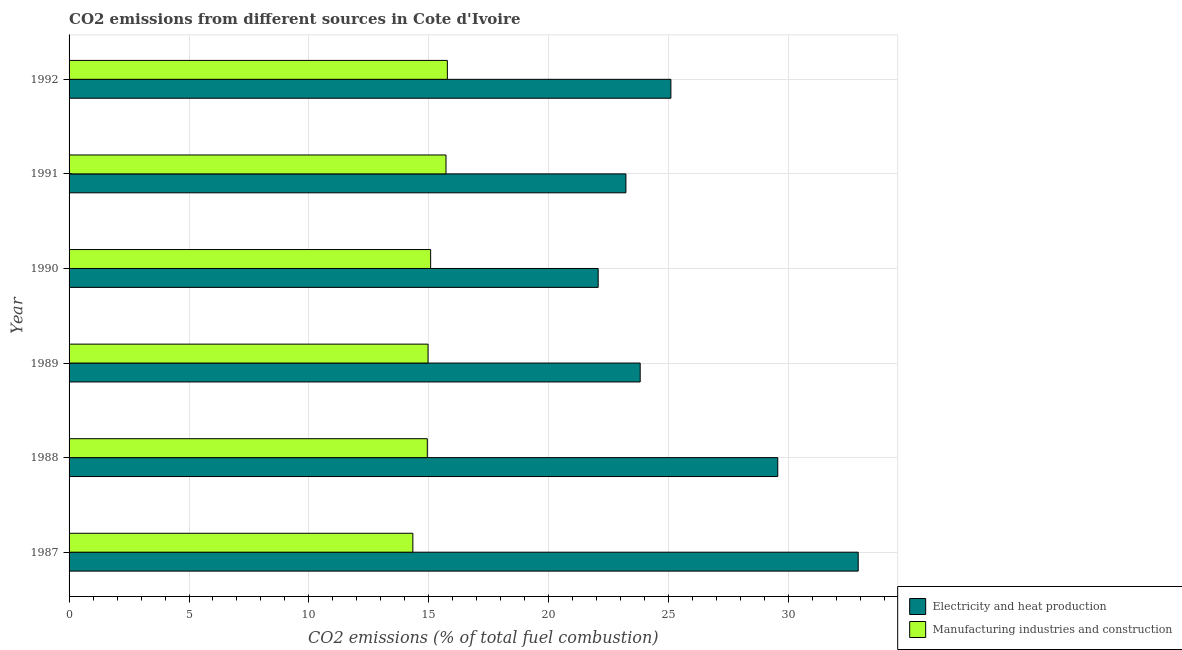How many different coloured bars are there?
Offer a very short reply. 2. How many groups of bars are there?
Offer a very short reply. 6. Are the number of bars per tick equal to the number of legend labels?
Provide a short and direct response. Yes. Are the number of bars on each tick of the Y-axis equal?
Offer a very short reply. Yes. How many bars are there on the 4th tick from the top?
Provide a succinct answer. 2. In how many cases, is the number of bars for a given year not equal to the number of legend labels?
Keep it short and to the point. 0. What is the co2 emissions due to manufacturing industries in 1987?
Your answer should be very brief. 14.33. Across all years, what is the maximum co2 emissions due to electricity and heat production?
Keep it short and to the point. 32.9. Across all years, what is the minimum co2 emissions due to manufacturing industries?
Keep it short and to the point. 14.33. In which year was the co2 emissions due to manufacturing industries maximum?
Provide a succinct answer. 1992. In which year was the co2 emissions due to electricity and heat production minimum?
Offer a terse response. 1990. What is the total co2 emissions due to electricity and heat production in the graph?
Provide a succinct answer. 156.62. What is the difference between the co2 emissions due to electricity and heat production in 1989 and that in 1990?
Keep it short and to the point. 1.75. What is the difference between the co2 emissions due to electricity and heat production in 1990 and the co2 emissions due to manufacturing industries in 1992?
Offer a very short reply. 6.29. What is the average co2 emissions due to manufacturing industries per year?
Ensure brevity in your answer.  15.13. In how many years, is the co2 emissions due to electricity and heat production greater than 24 %?
Keep it short and to the point. 3. What is the ratio of the co2 emissions due to manufacturing industries in 1987 to that in 1992?
Your answer should be very brief. 0.91. Is the difference between the co2 emissions due to manufacturing industries in 1988 and 1992 greater than the difference between the co2 emissions due to electricity and heat production in 1988 and 1992?
Make the answer very short. No. What is the difference between the highest and the second highest co2 emissions due to electricity and heat production?
Offer a terse response. 3.35. What is the difference between the highest and the lowest co2 emissions due to electricity and heat production?
Your answer should be very brief. 10.84. In how many years, is the co2 emissions due to manufacturing industries greater than the average co2 emissions due to manufacturing industries taken over all years?
Your answer should be compact. 2. What does the 1st bar from the top in 1988 represents?
Your response must be concise. Manufacturing industries and construction. What does the 2nd bar from the bottom in 1992 represents?
Offer a very short reply. Manufacturing industries and construction. How many bars are there?
Ensure brevity in your answer.  12. Does the graph contain any zero values?
Give a very brief answer. No. Where does the legend appear in the graph?
Your answer should be compact. Bottom right. How are the legend labels stacked?
Offer a terse response. Vertical. What is the title of the graph?
Your response must be concise. CO2 emissions from different sources in Cote d'Ivoire. Does "Stunting" appear as one of the legend labels in the graph?
Offer a very short reply. No. What is the label or title of the X-axis?
Offer a very short reply. CO2 emissions (% of total fuel combustion). What is the label or title of the Y-axis?
Your answer should be compact. Year. What is the CO2 emissions (% of total fuel combustion) in Electricity and heat production in 1987?
Make the answer very short. 32.9. What is the CO2 emissions (% of total fuel combustion) of Manufacturing industries and construction in 1987?
Ensure brevity in your answer.  14.33. What is the CO2 emissions (% of total fuel combustion) of Electricity and heat production in 1988?
Give a very brief answer. 29.55. What is the CO2 emissions (% of total fuel combustion) in Manufacturing industries and construction in 1988?
Provide a succinct answer. 14.94. What is the CO2 emissions (% of total fuel combustion) in Electricity and heat production in 1989?
Ensure brevity in your answer.  23.81. What is the CO2 emissions (% of total fuel combustion) of Manufacturing industries and construction in 1989?
Keep it short and to the point. 14.97. What is the CO2 emissions (% of total fuel combustion) in Electricity and heat production in 1990?
Your answer should be compact. 22.06. What is the CO2 emissions (% of total fuel combustion) of Manufacturing industries and construction in 1990?
Your response must be concise. 15.07. What is the CO2 emissions (% of total fuel combustion) in Electricity and heat production in 1991?
Keep it short and to the point. 23.21. What is the CO2 emissions (% of total fuel combustion) of Manufacturing industries and construction in 1991?
Your answer should be very brief. 15.71. What is the CO2 emissions (% of total fuel combustion) of Electricity and heat production in 1992?
Your answer should be very brief. 25.09. What is the CO2 emissions (% of total fuel combustion) of Manufacturing industries and construction in 1992?
Offer a very short reply. 15.77. Across all years, what is the maximum CO2 emissions (% of total fuel combustion) of Electricity and heat production?
Offer a very short reply. 32.9. Across all years, what is the maximum CO2 emissions (% of total fuel combustion) in Manufacturing industries and construction?
Offer a terse response. 15.77. Across all years, what is the minimum CO2 emissions (% of total fuel combustion) in Electricity and heat production?
Your answer should be very brief. 22.06. Across all years, what is the minimum CO2 emissions (% of total fuel combustion) in Manufacturing industries and construction?
Provide a short and direct response. 14.33. What is the total CO2 emissions (% of total fuel combustion) of Electricity and heat production in the graph?
Provide a succinct answer. 156.62. What is the total CO2 emissions (% of total fuel combustion) of Manufacturing industries and construction in the graph?
Ensure brevity in your answer.  90.79. What is the difference between the CO2 emissions (% of total fuel combustion) of Electricity and heat production in 1987 and that in 1988?
Your response must be concise. 3.35. What is the difference between the CO2 emissions (% of total fuel combustion) of Manufacturing industries and construction in 1987 and that in 1988?
Ensure brevity in your answer.  -0.6. What is the difference between the CO2 emissions (% of total fuel combustion) in Electricity and heat production in 1987 and that in 1989?
Your answer should be compact. 9.09. What is the difference between the CO2 emissions (% of total fuel combustion) in Manufacturing industries and construction in 1987 and that in 1989?
Provide a succinct answer. -0.63. What is the difference between the CO2 emissions (% of total fuel combustion) in Electricity and heat production in 1987 and that in 1990?
Ensure brevity in your answer.  10.84. What is the difference between the CO2 emissions (% of total fuel combustion) in Manufacturing industries and construction in 1987 and that in 1990?
Offer a very short reply. -0.74. What is the difference between the CO2 emissions (% of total fuel combustion) of Electricity and heat production in 1987 and that in 1991?
Your answer should be compact. 9.68. What is the difference between the CO2 emissions (% of total fuel combustion) of Manufacturing industries and construction in 1987 and that in 1991?
Your answer should be compact. -1.38. What is the difference between the CO2 emissions (% of total fuel combustion) in Electricity and heat production in 1987 and that in 1992?
Provide a succinct answer. 7.81. What is the difference between the CO2 emissions (% of total fuel combustion) in Manufacturing industries and construction in 1987 and that in 1992?
Provide a succinct answer. -1.44. What is the difference between the CO2 emissions (% of total fuel combustion) of Electricity and heat production in 1988 and that in 1989?
Your answer should be very brief. 5.74. What is the difference between the CO2 emissions (% of total fuel combustion) in Manufacturing industries and construction in 1988 and that in 1989?
Keep it short and to the point. -0.03. What is the difference between the CO2 emissions (% of total fuel combustion) in Electricity and heat production in 1988 and that in 1990?
Keep it short and to the point. 7.49. What is the difference between the CO2 emissions (% of total fuel combustion) of Manufacturing industries and construction in 1988 and that in 1990?
Provide a short and direct response. -0.14. What is the difference between the CO2 emissions (% of total fuel combustion) of Electricity and heat production in 1988 and that in 1991?
Make the answer very short. 6.33. What is the difference between the CO2 emissions (% of total fuel combustion) in Manufacturing industries and construction in 1988 and that in 1991?
Offer a very short reply. -0.78. What is the difference between the CO2 emissions (% of total fuel combustion) in Electricity and heat production in 1988 and that in 1992?
Ensure brevity in your answer.  4.46. What is the difference between the CO2 emissions (% of total fuel combustion) of Manufacturing industries and construction in 1988 and that in 1992?
Give a very brief answer. -0.84. What is the difference between the CO2 emissions (% of total fuel combustion) of Electricity and heat production in 1989 and that in 1990?
Keep it short and to the point. 1.75. What is the difference between the CO2 emissions (% of total fuel combustion) of Manufacturing industries and construction in 1989 and that in 1990?
Offer a terse response. -0.11. What is the difference between the CO2 emissions (% of total fuel combustion) of Electricity and heat production in 1989 and that in 1991?
Your response must be concise. 0.6. What is the difference between the CO2 emissions (% of total fuel combustion) of Manufacturing industries and construction in 1989 and that in 1991?
Offer a terse response. -0.75. What is the difference between the CO2 emissions (% of total fuel combustion) of Electricity and heat production in 1989 and that in 1992?
Offer a terse response. -1.28. What is the difference between the CO2 emissions (% of total fuel combustion) in Manufacturing industries and construction in 1989 and that in 1992?
Your response must be concise. -0.8. What is the difference between the CO2 emissions (% of total fuel combustion) of Electricity and heat production in 1990 and that in 1991?
Offer a very short reply. -1.16. What is the difference between the CO2 emissions (% of total fuel combustion) in Manufacturing industries and construction in 1990 and that in 1991?
Your answer should be very brief. -0.64. What is the difference between the CO2 emissions (% of total fuel combustion) of Electricity and heat production in 1990 and that in 1992?
Offer a very short reply. -3.03. What is the difference between the CO2 emissions (% of total fuel combustion) in Manufacturing industries and construction in 1990 and that in 1992?
Make the answer very short. -0.7. What is the difference between the CO2 emissions (% of total fuel combustion) of Electricity and heat production in 1991 and that in 1992?
Offer a very short reply. -1.88. What is the difference between the CO2 emissions (% of total fuel combustion) of Manufacturing industries and construction in 1991 and that in 1992?
Provide a succinct answer. -0.06. What is the difference between the CO2 emissions (% of total fuel combustion) of Electricity and heat production in 1987 and the CO2 emissions (% of total fuel combustion) of Manufacturing industries and construction in 1988?
Ensure brevity in your answer.  17.96. What is the difference between the CO2 emissions (% of total fuel combustion) of Electricity and heat production in 1987 and the CO2 emissions (% of total fuel combustion) of Manufacturing industries and construction in 1989?
Offer a very short reply. 17.93. What is the difference between the CO2 emissions (% of total fuel combustion) of Electricity and heat production in 1987 and the CO2 emissions (% of total fuel combustion) of Manufacturing industries and construction in 1990?
Offer a very short reply. 17.83. What is the difference between the CO2 emissions (% of total fuel combustion) in Electricity and heat production in 1987 and the CO2 emissions (% of total fuel combustion) in Manufacturing industries and construction in 1991?
Your response must be concise. 17.18. What is the difference between the CO2 emissions (% of total fuel combustion) in Electricity and heat production in 1987 and the CO2 emissions (% of total fuel combustion) in Manufacturing industries and construction in 1992?
Provide a short and direct response. 17.13. What is the difference between the CO2 emissions (% of total fuel combustion) of Electricity and heat production in 1988 and the CO2 emissions (% of total fuel combustion) of Manufacturing industries and construction in 1989?
Make the answer very short. 14.58. What is the difference between the CO2 emissions (% of total fuel combustion) in Electricity and heat production in 1988 and the CO2 emissions (% of total fuel combustion) in Manufacturing industries and construction in 1990?
Provide a short and direct response. 14.47. What is the difference between the CO2 emissions (% of total fuel combustion) in Electricity and heat production in 1988 and the CO2 emissions (% of total fuel combustion) in Manufacturing industries and construction in 1991?
Provide a short and direct response. 13.83. What is the difference between the CO2 emissions (% of total fuel combustion) in Electricity and heat production in 1988 and the CO2 emissions (% of total fuel combustion) in Manufacturing industries and construction in 1992?
Give a very brief answer. 13.77. What is the difference between the CO2 emissions (% of total fuel combustion) in Electricity and heat production in 1989 and the CO2 emissions (% of total fuel combustion) in Manufacturing industries and construction in 1990?
Offer a terse response. 8.74. What is the difference between the CO2 emissions (% of total fuel combustion) in Electricity and heat production in 1989 and the CO2 emissions (% of total fuel combustion) in Manufacturing industries and construction in 1991?
Offer a terse response. 8.1. What is the difference between the CO2 emissions (% of total fuel combustion) in Electricity and heat production in 1989 and the CO2 emissions (% of total fuel combustion) in Manufacturing industries and construction in 1992?
Your response must be concise. 8.04. What is the difference between the CO2 emissions (% of total fuel combustion) in Electricity and heat production in 1990 and the CO2 emissions (% of total fuel combustion) in Manufacturing industries and construction in 1991?
Offer a terse response. 6.34. What is the difference between the CO2 emissions (% of total fuel combustion) in Electricity and heat production in 1990 and the CO2 emissions (% of total fuel combustion) in Manufacturing industries and construction in 1992?
Offer a terse response. 6.29. What is the difference between the CO2 emissions (% of total fuel combustion) in Electricity and heat production in 1991 and the CO2 emissions (% of total fuel combustion) in Manufacturing industries and construction in 1992?
Give a very brief answer. 7.44. What is the average CO2 emissions (% of total fuel combustion) of Electricity and heat production per year?
Your answer should be very brief. 26.1. What is the average CO2 emissions (% of total fuel combustion) of Manufacturing industries and construction per year?
Offer a terse response. 15.13. In the year 1987, what is the difference between the CO2 emissions (% of total fuel combustion) in Electricity and heat production and CO2 emissions (% of total fuel combustion) in Manufacturing industries and construction?
Your answer should be compact. 18.57. In the year 1988, what is the difference between the CO2 emissions (% of total fuel combustion) of Electricity and heat production and CO2 emissions (% of total fuel combustion) of Manufacturing industries and construction?
Your response must be concise. 14.61. In the year 1989, what is the difference between the CO2 emissions (% of total fuel combustion) in Electricity and heat production and CO2 emissions (% of total fuel combustion) in Manufacturing industries and construction?
Your answer should be compact. 8.84. In the year 1990, what is the difference between the CO2 emissions (% of total fuel combustion) of Electricity and heat production and CO2 emissions (% of total fuel combustion) of Manufacturing industries and construction?
Provide a succinct answer. 6.99. In the year 1991, what is the difference between the CO2 emissions (% of total fuel combustion) in Electricity and heat production and CO2 emissions (% of total fuel combustion) in Manufacturing industries and construction?
Give a very brief answer. 7.5. In the year 1992, what is the difference between the CO2 emissions (% of total fuel combustion) in Electricity and heat production and CO2 emissions (% of total fuel combustion) in Manufacturing industries and construction?
Ensure brevity in your answer.  9.32. What is the ratio of the CO2 emissions (% of total fuel combustion) of Electricity and heat production in 1987 to that in 1988?
Your response must be concise. 1.11. What is the ratio of the CO2 emissions (% of total fuel combustion) in Manufacturing industries and construction in 1987 to that in 1988?
Provide a succinct answer. 0.96. What is the ratio of the CO2 emissions (% of total fuel combustion) in Electricity and heat production in 1987 to that in 1989?
Ensure brevity in your answer.  1.38. What is the ratio of the CO2 emissions (% of total fuel combustion) in Manufacturing industries and construction in 1987 to that in 1989?
Ensure brevity in your answer.  0.96. What is the ratio of the CO2 emissions (% of total fuel combustion) of Electricity and heat production in 1987 to that in 1990?
Provide a succinct answer. 1.49. What is the ratio of the CO2 emissions (% of total fuel combustion) in Manufacturing industries and construction in 1987 to that in 1990?
Your answer should be compact. 0.95. What is the ratio of the CO2 emissions (% of total fuel combustion) in Electricity and heat production in 1987 to that in 1991?
Your response must be concise. 1.42. What is the ratio of the CO2 emissions (% of total fuel combustion) of Manufacturing industries and construction in 1987 to that in 1991?
Ensure brevity in your answer.  0.91. What is the ratio of the CO2 emissions (% of total fuel combustion) in Electricity and heat production in 1987 to that in 1992?
Your answer should be very brief. 1.31. What is the ratio of the CO2 emissions (% of total fuel combustion) of Manufacturing industries and construction in 1987 to that in 1992?
Your answer should be compact. 0.91. What is the ratio of the CO2 emissions (% of total fuel combustion) in Electricity and heat production in 1988 to that in 1989?
Offer a terse response. 1.24. What is the ratio of the CO2 emissions (% of total fuel combustion) of Manufacturing industries and construction in 1988 to that in 1989?
Provide a succinct answer. 1. What is the ratio of the CO2 emissions (% of total fuel combustion) in Electricity and heat production in 1988 to that in 1990?
Offer a very short reply. 1.34. What is the ratio of the CO2 emissions (% of total fuel combustion) in Electricity and heat production in 1988 to that in 1991?
Keep it short and to the point. 1.27. What is the ratio of the CO2 emissions (% of total fuel combustion) in Manufacturing industries and construction in 1988 to that in 1991?
Your answer should be very brief. 0.95. What is the ratio of the CO2 emissions (% of total fuel combustion) in Electricity and heat production in 1988 to that in 1992?
Provide a succinct answer. 1.18. What is the ratio of the CO2 emissions (% of total fuel combustion) of Manufacturing industries and construction in 1988 to that in 1992?
Offer a very short reply. 0.95. What is the ratio of the CO2 emissions (% of total fuel combustion) of Electricity and heat production in 1989 to that in 1990?
Your response must be concise. 1.08. What is the ratio of the CO2 emissions (% of total fuel combustion) of Electricity and heat production in 1989 to that in 1991?
Keep it short and to the point. 1.03. What is the ratio of the CO2 emissions (% of total fuel combustion) in Manufacturing industries and construction in 1989 to that in 1991?
Provide a succinct answer. 0.95. What is the ratio of the CO2 emissions (% of total fuel combustion) of Electricity and heat production in 1989 to that in 1992?
Your response must be concise. 0.95. What is the ratio of the CO2 emissions (% of total fuel combustion) of Manufacturing industries and construction in 1989 to that in 1992?
Your answer should be very brief. 0.95. What is the ratio of the CO2 emissions (% of total fuel combustion) of Electricity and heat production in 1990 to that in 1991?
Provide a succinct answer. 0.95. What is the ratio of the CO2 emissions (% of total fuel combustion) of Manufacturing industries and construction in 1990 to that in 1991?
Make the answer very short. 0.96. What is the ratio of the CO2 emissions (% of total fuel combustion) of Electricity and heat production in 1990 to that in 1992?
Ensure brevity in your answer.  0.88. What is the ratio of the CO2 emissions (% of total fuel combustion) of Manufacturing industries and construction in 1990 to that in 1992?
Your answer should be very brief. 0.96. What is the ratio of the CO2 emissions (% of total fuel combustion) in Electricity and heat production in 1991 to that in 1992?
Ensure brevity in your answer.  0.93. What is the ratio of the CO2 emissions (% of total fuel combustion) of Manufacturing industries and construction in 1991 to that in 1992?
Offer a very short reply. 1. What is the difference between the highest and the second highest CO2 emissions (% of total fuel combustion) of Electricity and heat production?
Keep it short and to the point. 3.35. What is the difference between the highest and the second highest CO2 emissions (% of total fuel combustion) of Manufacturing industries and construction?
Offer a very short reply. 0.06. What is the difference between the highest and the lowest CO2 emissions (% of total fuel combustion) of Electricity and heat production?
Your answer should be very brief. 10.84. What is the difference between the highest and the lowest CO2 emissions (% of total fuel combustion) in Manufacturing industries and construction?
Your response must be concise. 1.44. 